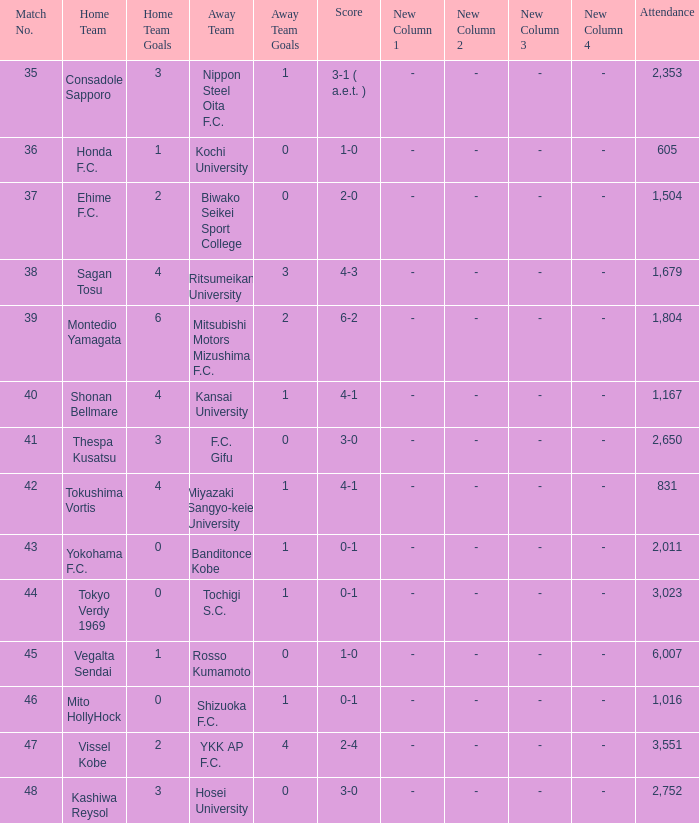After Match 43, what was the Attendance of the Match with a Score of 2-4? 3551.0. 